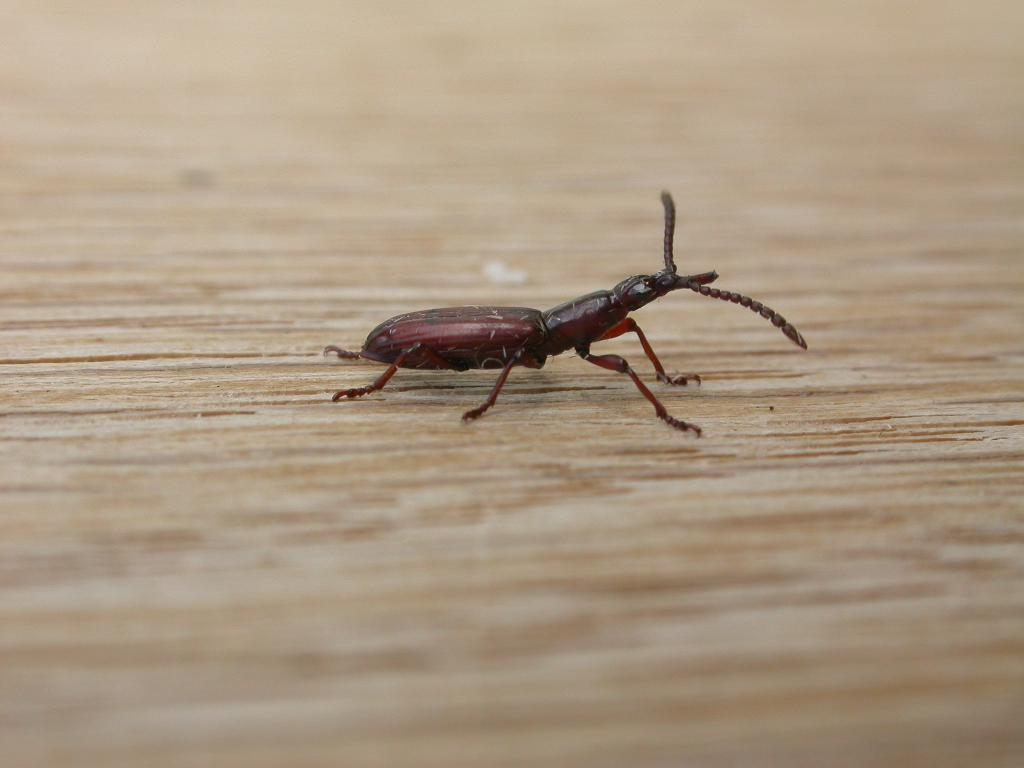What piece of furniture is present in the image? There is a table in the image. What is on the table in the image? There is an insect on the table. What type of chain is hanging from the ceiling in the image? There is no chain present in the image; it only features a table and an insect. What kind of clouds can be seen in the background of the image? There is no background or clouds visible in the image, as it only shows a table and an insect. 